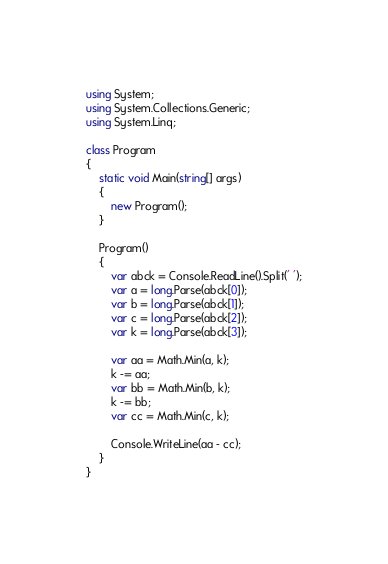<code> <loc_0><loc_0><loc_500><loc_500><_C#_>using System;
using System.Collections.Generic;
using System.Linq;

class Program
{
    static void Main(string[] args)
    {
        new Program();
    }

    Program()
    {
        var abck = Console.ReadLine().Split(' ');
        var a = long.Parse(abck[0]);
        var b = long.Parse(abck[1]);
        var c = long.Parse(abck[2]);
        var k = long.Parse(abck[3]);

        var aa = Math.Min(a, k);
        k -= aa;
        var bb = Math.Min(b, k);
        k -= bb;
        var cc = Math.Min(c, k);

        Console.WriteLine(aa - cc);
    }
}
</code> 